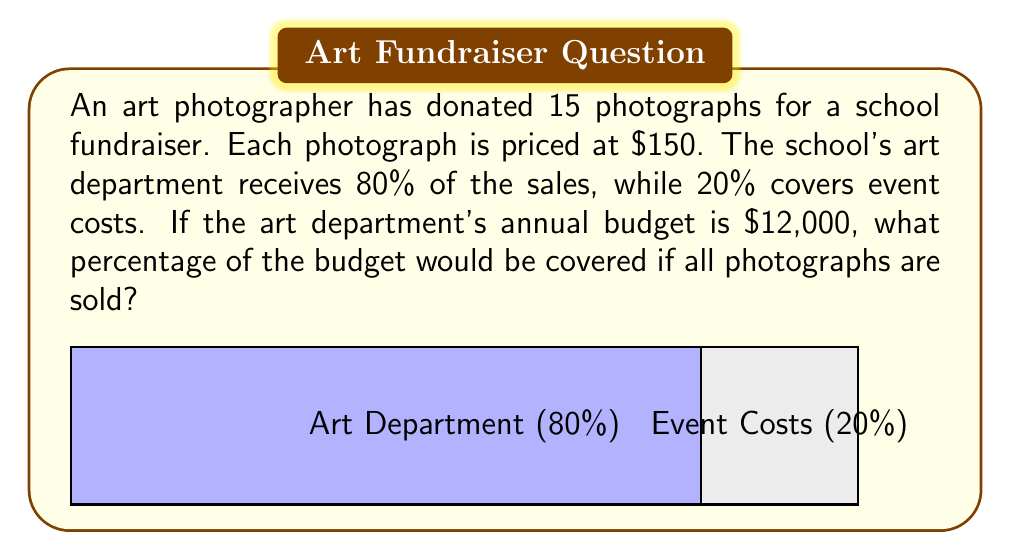Provide a solution to this math problem. Let's break this down step-by-step:

1) Calculate the total sales if all photographs are sold:
   $$15 \text{ photographs} \times \$150 \text{ per photograph} = \$2,250$$

2) Calculate the amount that goes to the art department (80% of sales):
   $$\$2,250 \times 0.80 = \$1,800$$

3) Set up the percentage calculation:
   Let $x$ be the percentage of the budget covered.
   $$\frac{\$1,800}{\$12,000} = \frac{x}{100}$$

4) Solve for $x$:
   $$x = \frac{\$1,800}{\$12,000} \times 100 = 0.15 \times 100 = 15$$

Therefore, if all photographs are sold, it would cover 15% of the art department's annual budget.
Answer: 15% 